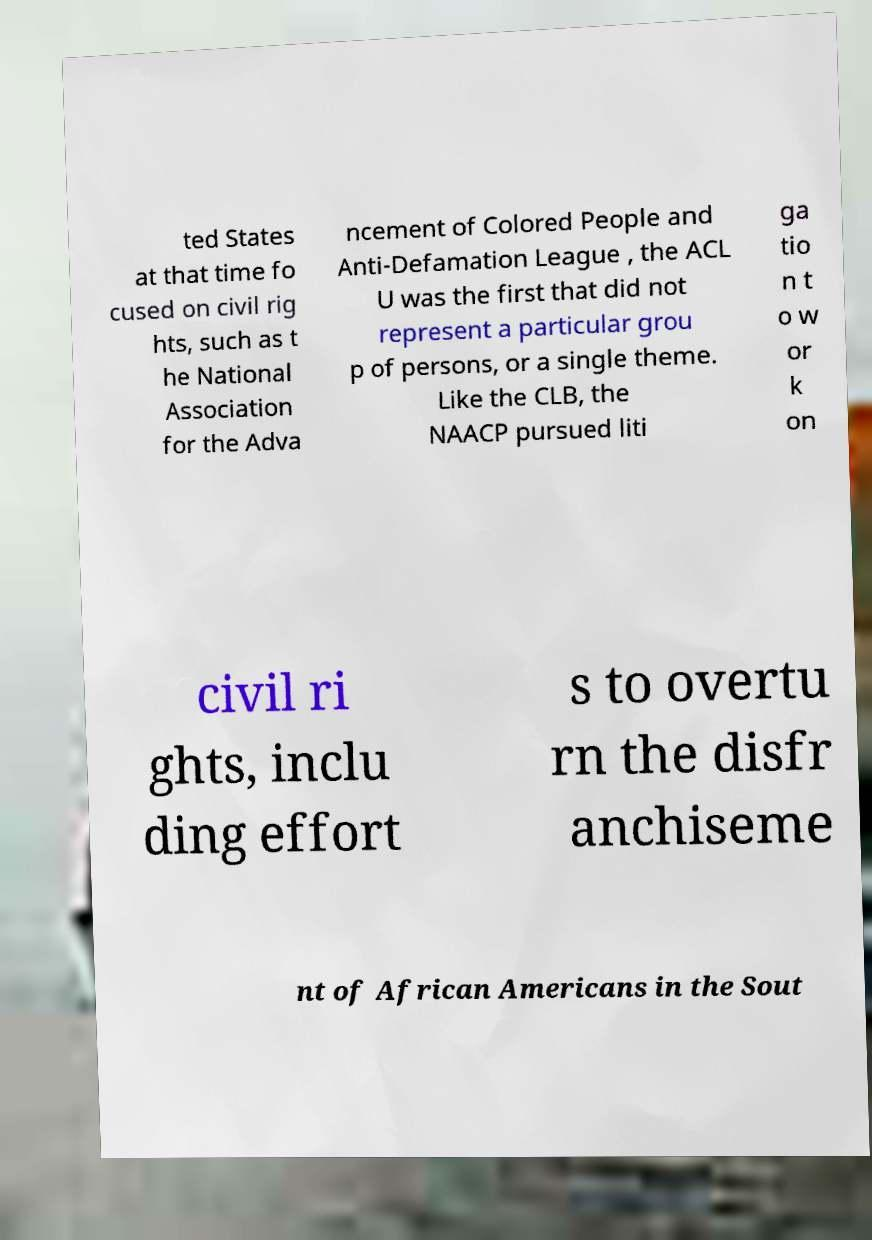What messages or text are displayed in this image? I need them in a readable, typed format. ted States at that time fo cused on civil rig hts, such as t he National Association for the Adva ncement of Colored People and Anti-Defamation League , the ACL U was the first that did not represent a particular grou p of persons, or a single theme. Like the CLB, the NAACP pursued liti ga tio n t o w or k on civil ri ghts, inclu ding effort s to overtu rn the disfr anchiseme nt of African Americans in the Sout 